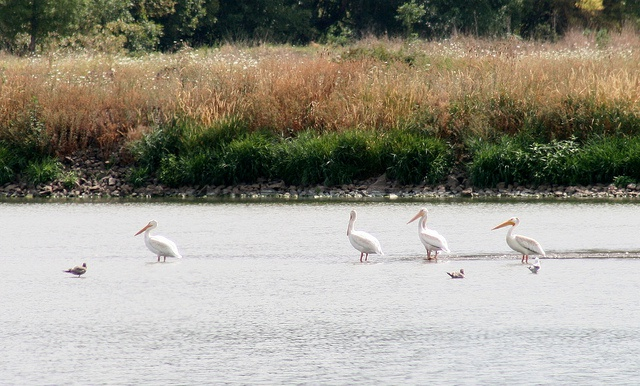Describe the objects in this image and their specific colors. I can see bird in darkgreen, lightgray, darkgray, and gray tones, bird in darkgreen, white, darkgray, and gray tones, bird in darkgreen, white, darkgray, and brown tones, bird in darkgreen, darkgray, lightgray, and gray tones, and bird in darkgreen, gray, darkgray, lightgray, and beige tones in this image. 